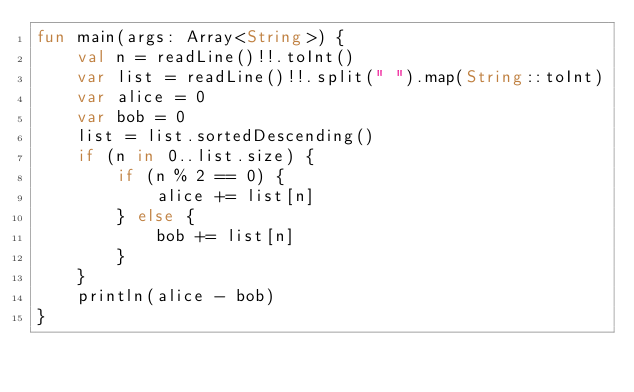<code> <loc_0><loc_0><loc_500><loc_500><_Kotlin_>fun main(args: Array<String>) {
    val n = readLine()!!.toInt()
    var list = readLine()!!.split(" ").map(String::toInt)
    var alice = 0
    var bob = 0
    list = list.sortedDescending()
    if (n in 0..list.size) {
        if (n % 2 == 0) {
            alice += list[n]
        } else {
            bob += list[n]
        }
    }
    println(alice - bob)
}</code> 